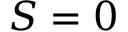<formula> <loc_0><loc_0><loc_500><loc_500>S = 0</formula> 